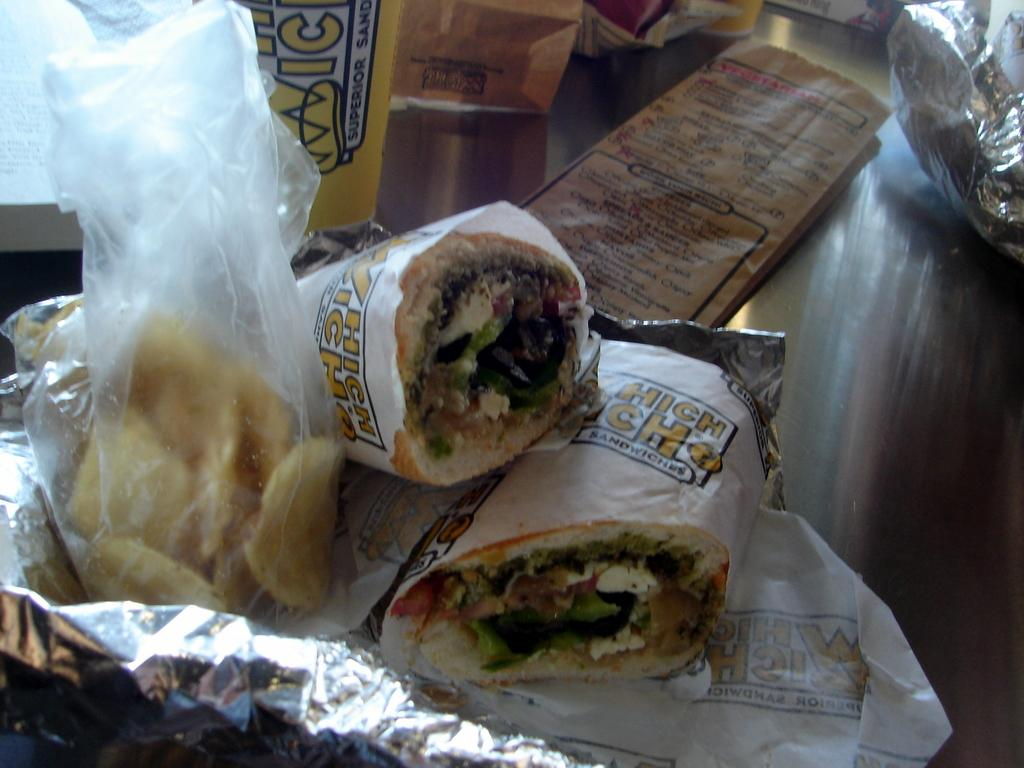What type of food can be seen in the image? There are sandwiches and potato chips in covers in the image. Are there any other food products visible in the image? Yes, there are other food products in the image. Where are the food items located? The items are on a table. How many ants can be seen crawling on the cushion in the image? There are no ants or cushions present in the image. What type of loaf is being served with the sandwiches in the image? There is no loaf visible in the image; only sandwiches and potato chips in covers are present. 